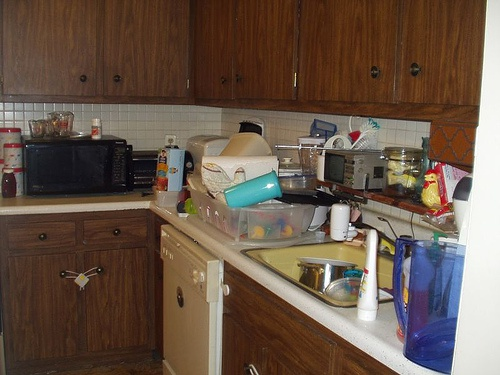Describe the objects in this image and their specific colors. I can see oven in black, gray, brown, darkgray, and tan tones, microwave in black and gray tones, sink in black, tan, olive, gray, and darkgray tones, toaster in black and gray tones, and tv in black and gray tones in this image. 